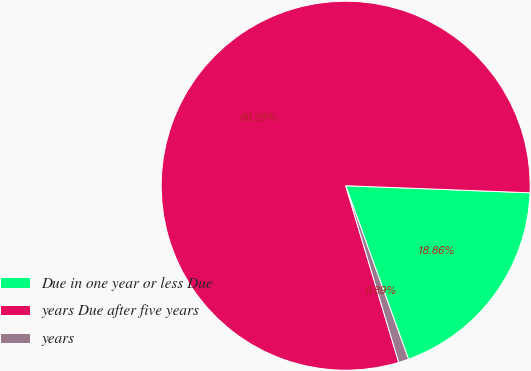<chart> <loc_0><loc_0><loc_500><loc_500><pie_chart><fcel>Due in one year or less Due<fcel>years Due after five years<fcel>years<nl><fcel>18.86%<fcel>80.25%<fcel>0.89%<nl></chart> 